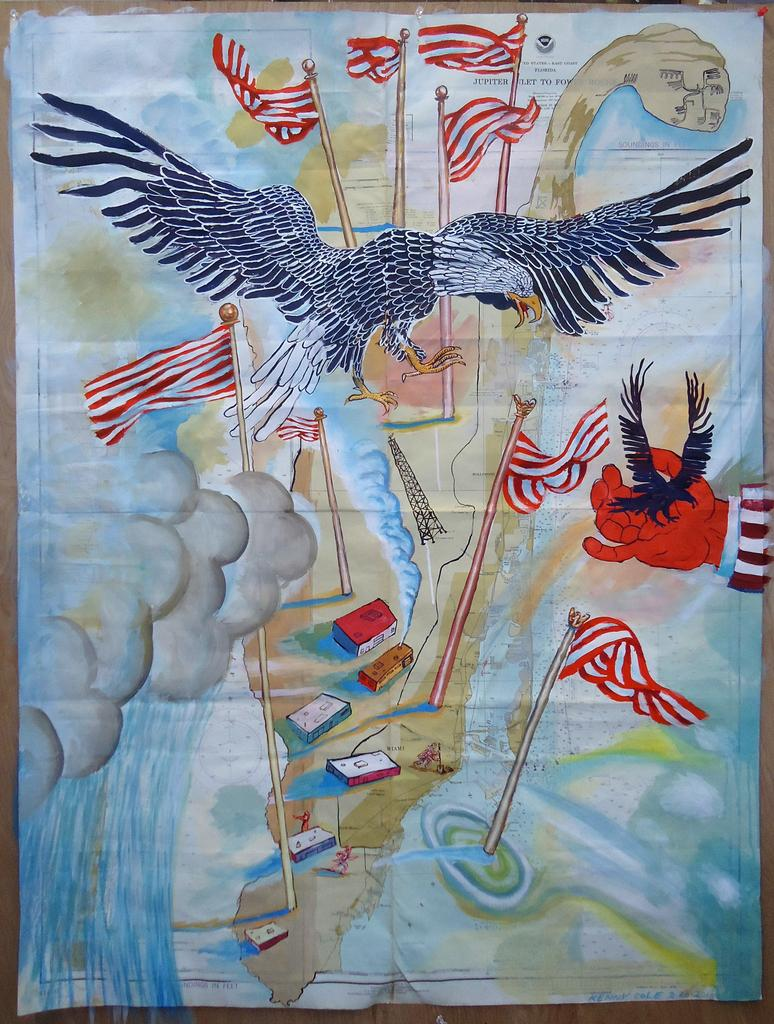What is the main subject of the image? The main subject of the image is a poster. What is featured on the poster? The poster contains flags and a vulture. How is the image created? The image appears to be a painting. What type of polish is the girl applying to her nails in the image? There is no girl or nail polish present in the image; it features a poster with flags and a vulture. What color is the vest worn by the person in the image? There is no person or vest present in the image; it features a poster with flags and a vulture. 